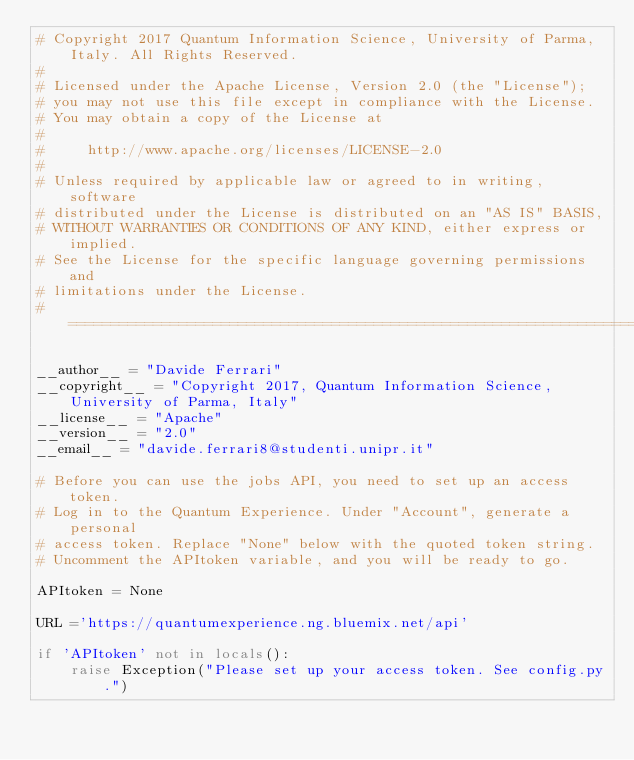<code> <loc_0><loc_0><loc_500><loc_500><_Python_># Copyright 2017 Quantum Information Science, University of Parma, Italy. All Rights Reserved.
#
# Licensed under the Apache License, Version 2.0 (the "License");
# you may not use this file except in compliance with the License.
# You may obtain a copy of the License at
#
#     http://www.apache.org/licenses/LICENSE-2.0
#
# Unless required by applicable law or agreed to in writing, software
# distributed under the License is distributed on an "AS IS" BASIS,
# WITHOUT WARRANTIES OR CONDITIONS OF ANY KIND, either express or implied.
# See the License for the specific language governing permissions and
# limitations under the License.
# =============================================================================

__author__ = "Davide Ferrari"
__copyright__ = "Copyright 2017, Quantum Information Science, University of Parma, Italy"
__license__ = "Apache"
__version__ = "2.0"
__email__ = "davide.ferrari8@studenti.unipr.it"

# Before you can use the jobs API, you need to set up an access token.
# Log in to the Quantum Experience. Under "Account", generate a personal
# access token. Replace "None" below with the quoted token string.
# Uncomment the APItoken variable, and you will be ready to go.

APItoken = None

URL ='https://quantumexperience.ng.bluemix.net/api'

if 'APItoken' not in locals():
    raise Exception("Please set up your access token. See config.py.")
</code> 